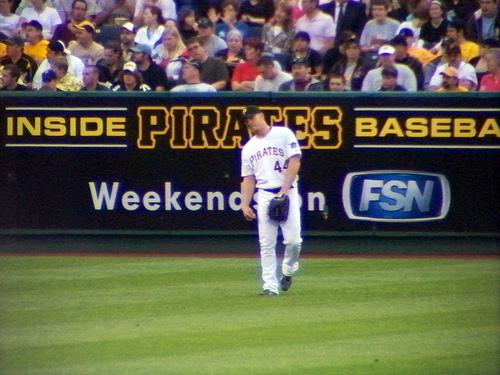Question: what sport are they playing?
Choices:
A. Basketball.
B. Hockey.
C. Soccer.
D. Baseball.
Answer with the letter. Answer: D Question: where are the fans?
Choices:
A. In front of the wall.
B. Behind the wall.
C. In the bleachers.
D. In the outfield.
Answer with the letter. Answer: B Question: what channel is advertised on banner?
Choices:
A. Espn.
B. Bet.
C. Mtv.
D. FSN.
Answer with the letter. Answer: D 